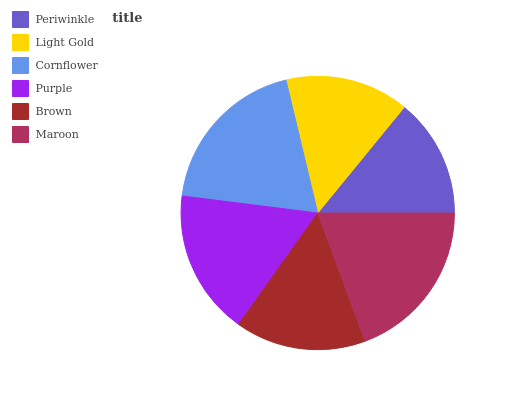Is Periwinkle the minimum?
Answer yes or no. Yes. Is Maroon the maximum?
Answer yes or no. Yes. Is Light Gold the minimum?
Answer yes or no. No. Is Light Gold the maximum?
Answer yes or no. No. Is Light Gold greater than Periwinkle?
Answer yes or no. Yes. Is Periwinkle less than Light Gold?
Answer yes or no. Yes. Is Periwinkle greater than Light Gold?
Answer yes or no. No. Is Light Gold less than Periwinkle?
Answer yes or no. No. Is Purple the high median?
Answer yes or no. Yes. Is Brown the low median?
Answer yes or no. Yes. Is Maroon the high median?
Answer yes or no. No. Is Light Gold the low median?
Answer yes or no. No. 